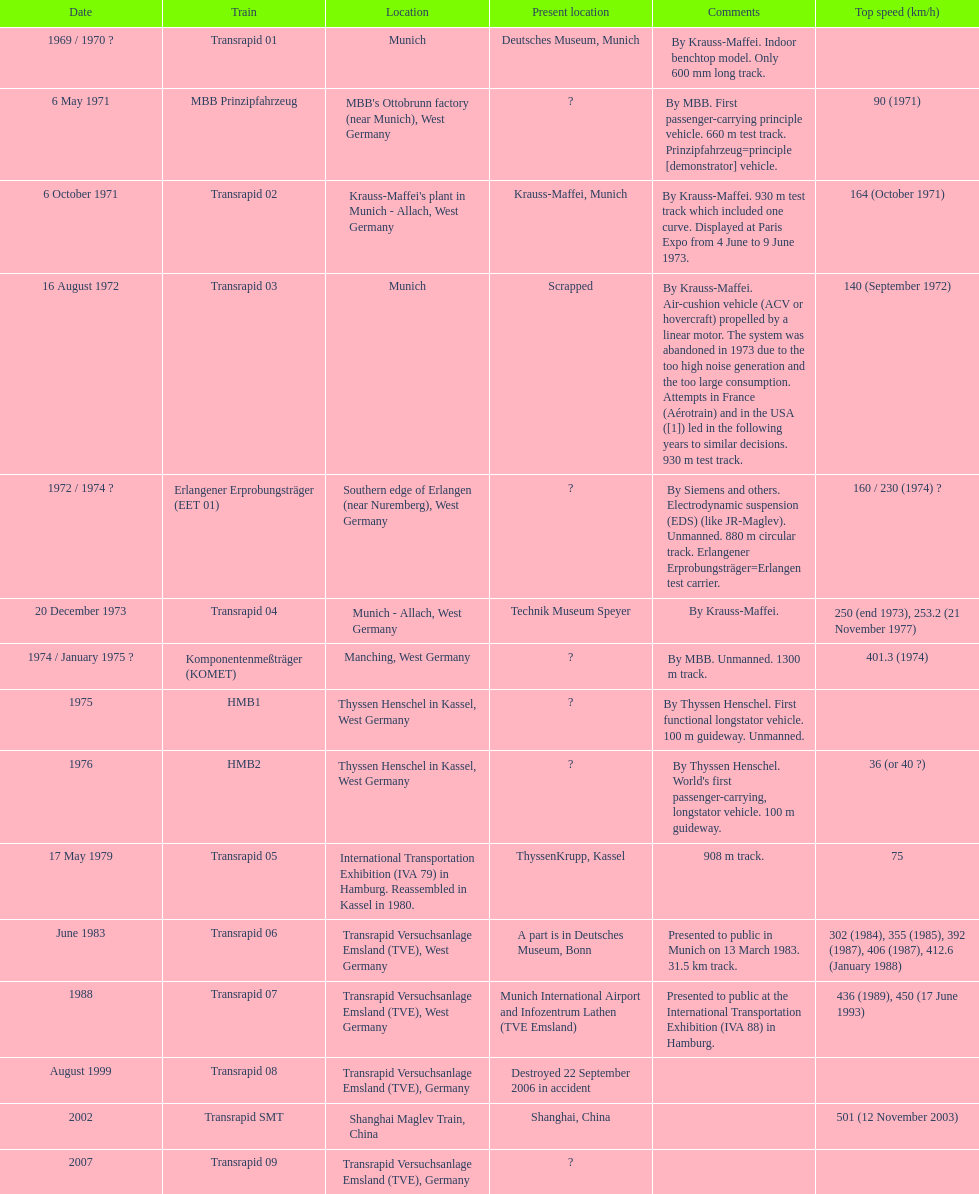High noise generation and too large consumption led to what train being scrapped? Transrapid 03. 